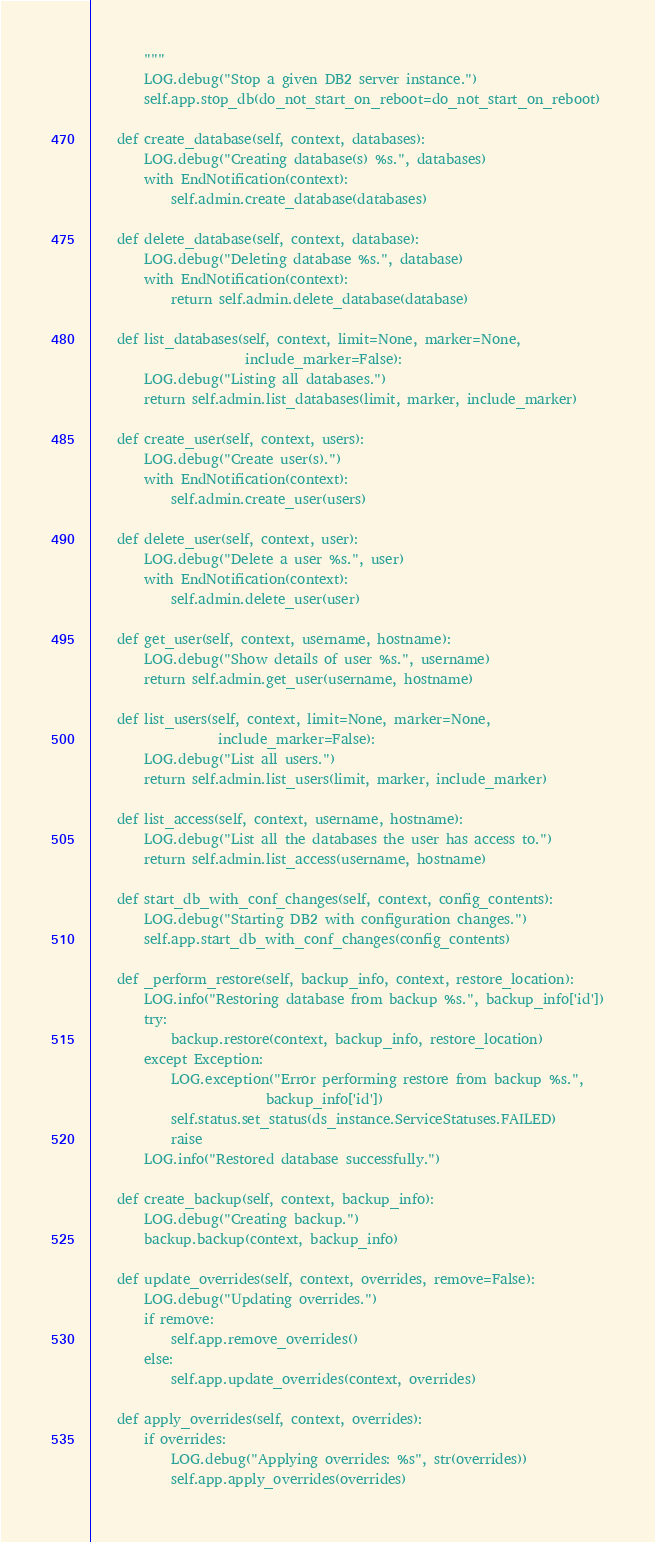<code> <loc_0><loc_0><loc_500><loc_500><_Python_>        """
        LOG.debug("Stop a given DB2 server instance.")
        self.app.stop_db(do_not_start_on_reboot=do_not_start_on_reboot)

    def create_database(self, context, databases):
        LOG.debug("Creating database(s) %s.", databases)
        with EndNotification(context):
            self.admin.create_database(databases)

    def delete_database(self, context, database):
        LOG.debug("Deleting database %s.", database)
        with EndNotification(context):
            return self.admin.delete_database(database)

    def list_databases(self, context, limit=None, marker=None,
                       include_marker=False):
        LOG.debug("Listing all databases.")
        return self.admin.list_databases(limit, marker, include_marker)

    def create_user(self, context, users):
        LOG.debug("Create user(s).")
        with EndNotification(context):
            self.admin.create_user(users)

    def delete_user(self, context, user):
        LOG.debug("Delete a user %s.", user)
        with EndNotification(context):
            self.admin.delete_user(user)

    def get_user(self, context, username, hostname):
        LOG.debug("Show details of user %s.", username)
        return self.admin.get_user(username, hostname)

    def list_users(self, context, limit=None, marker=None,
                   include_marker=False):
        LOG.debug("List all users.")
        return self.admin.list_users(limit, marker, include_marker)

    def list_access(self, context, username, hostname):
        LOG.debug("List all the databases the user has access to.")
        return self.admin.list_access(username, hostname)

    def start_db_with_conf_changes(self, context, config_contents):
        LOG.debug("Starting DB2 with configuration changes.")
        self.app.start_db_with_conf_changes(config_contents)

    def _perform_restore(self, backup_info, context, restore_location):
        LOG.info("Restoring database from backup %s.", backup_info['id'])
        try:
            backup.restore(context, backup_info, restore_location)
        except Exception:
            LOG.exception("Error performing restore from backup %s.",
                          backup_info['id'])
            self.status.set_status(ds_instance.ServiceStatuses.FAILED)
            raise
        LOG.info("Restored database successfully.")

    def create_backup(self, context, backup_info):
        LOG.debug("Creating backup.")
        backup.backup(context, backup_info)

    def update_overrides(self, context, overrides, remove=False):
        LOG.debug("Updating overrides.")
        if remove:
            self.app.remove_overrides()
        else:
            self.app.update_overrides(context, overrides)

    def apply_overrides(self, context, overrides):
        if overrides:
            LOG.debug("Applying overrides: %s", str(overrides))
            self.app.apply_overrides(overrides)
</code> 